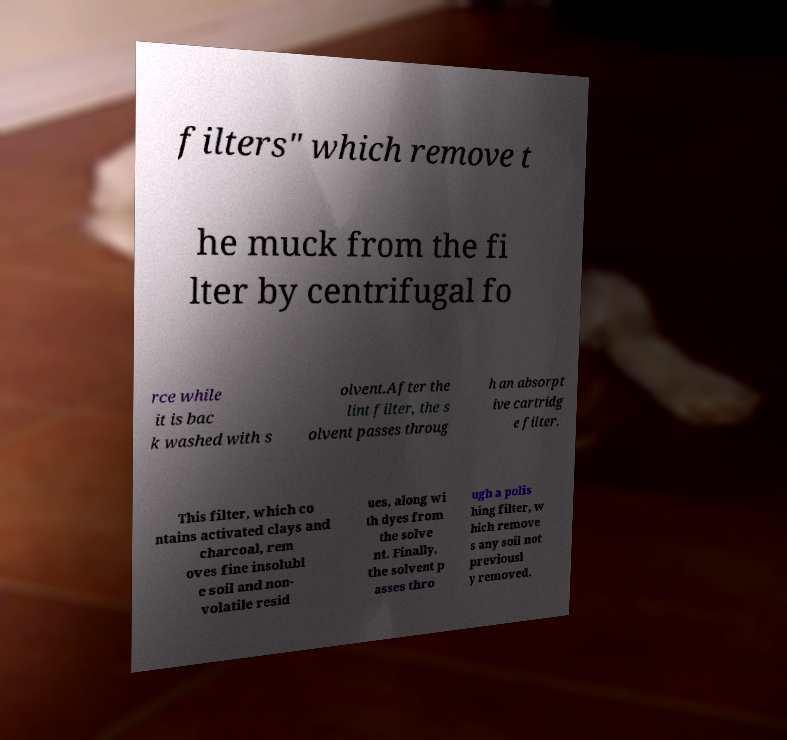For documentation purposes, I need the text within this image transcribed. Could you provide that? filters" which remove t he muck from the fi lter by centrifugal fo rce while it is bac k washed with s olvent.After the lint filter, the s olvent passes throug h an absorpt ive cartridg e filter. This filter, which co ntains activated clays and charcoal, rem oves fine insolubl e soil and non- volatile resid ues, along wi th dyes from the solve nt. Finally, the solvent p asses thro ugh a polis hing filter, w hich remove s any soil not previousl y removed. 